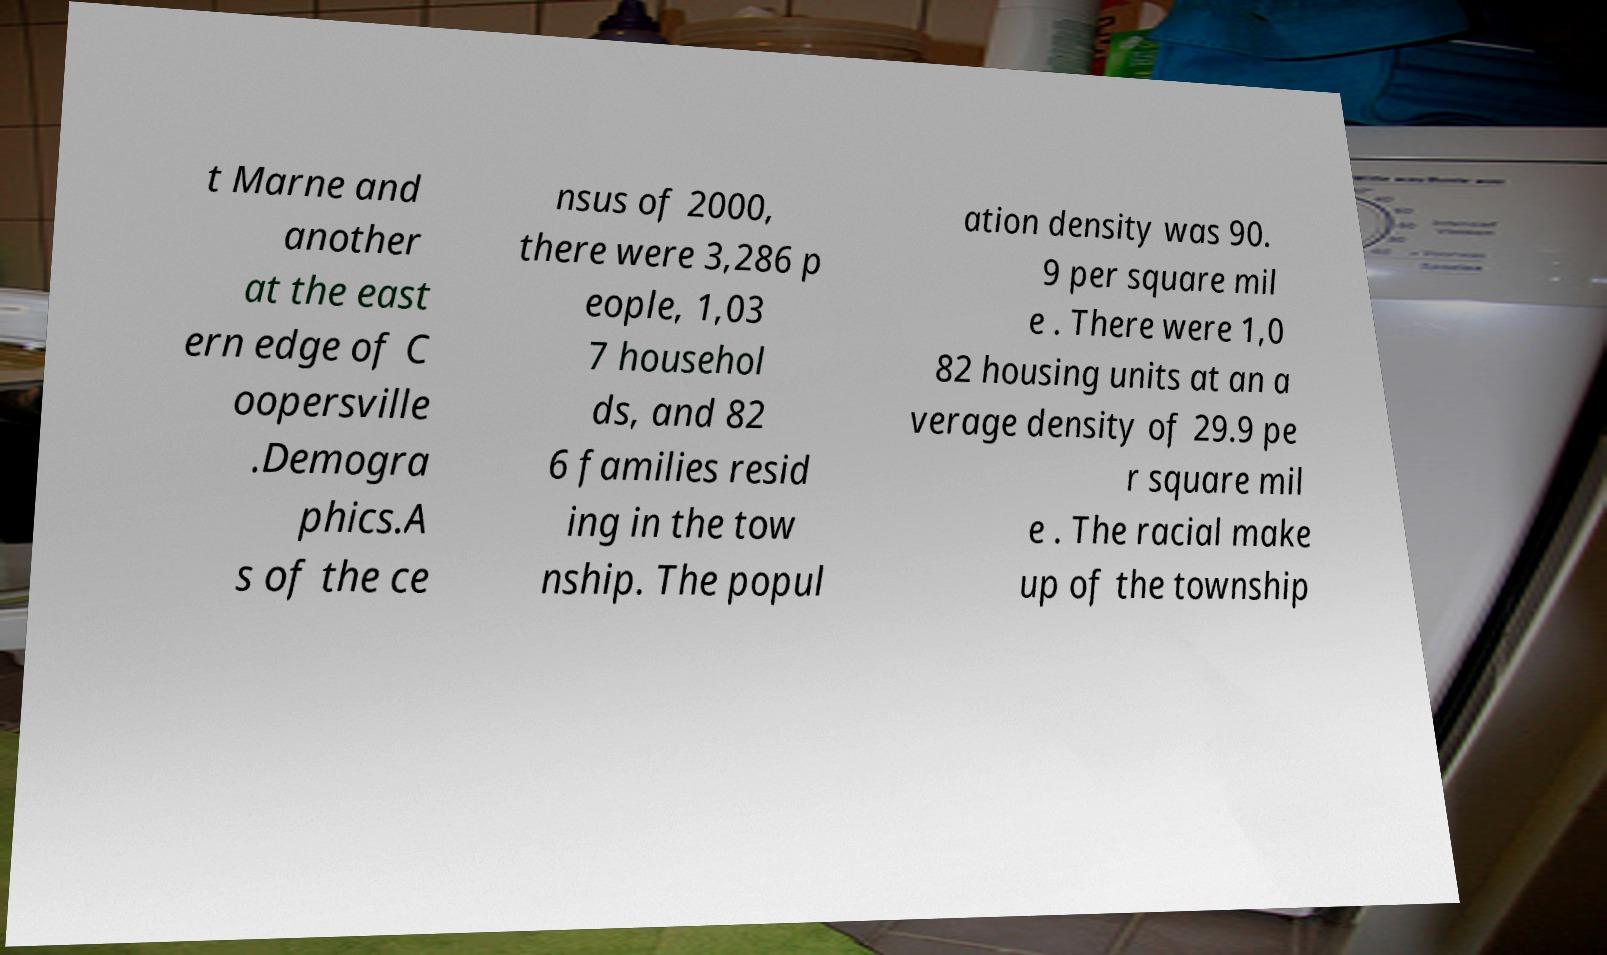Can you read and provide the text displayed in the image?This photo seems to have some interesting text. Can you extract and type it out for me? t Marne and another at the east ern edge of C oopersville .Demogra phics.A s of the ce nsus of 2000, there were 3,286 p eople, 1,03 7 househol ds, and 82 6 families resid ing in the tow nship. The popul ation density was 90. 9 per square mil e . There were 1,0 82 housing units at an a verage density of 29.9 pe r square mil e . The racial make up of the township 